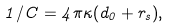Convert formula to latex. <formula><loc_0><loc_0><loc_500><loc_500>1 / C = 4 \pi \kappa ( d _ { 0 } + r _ { s } ) ,</formula> 